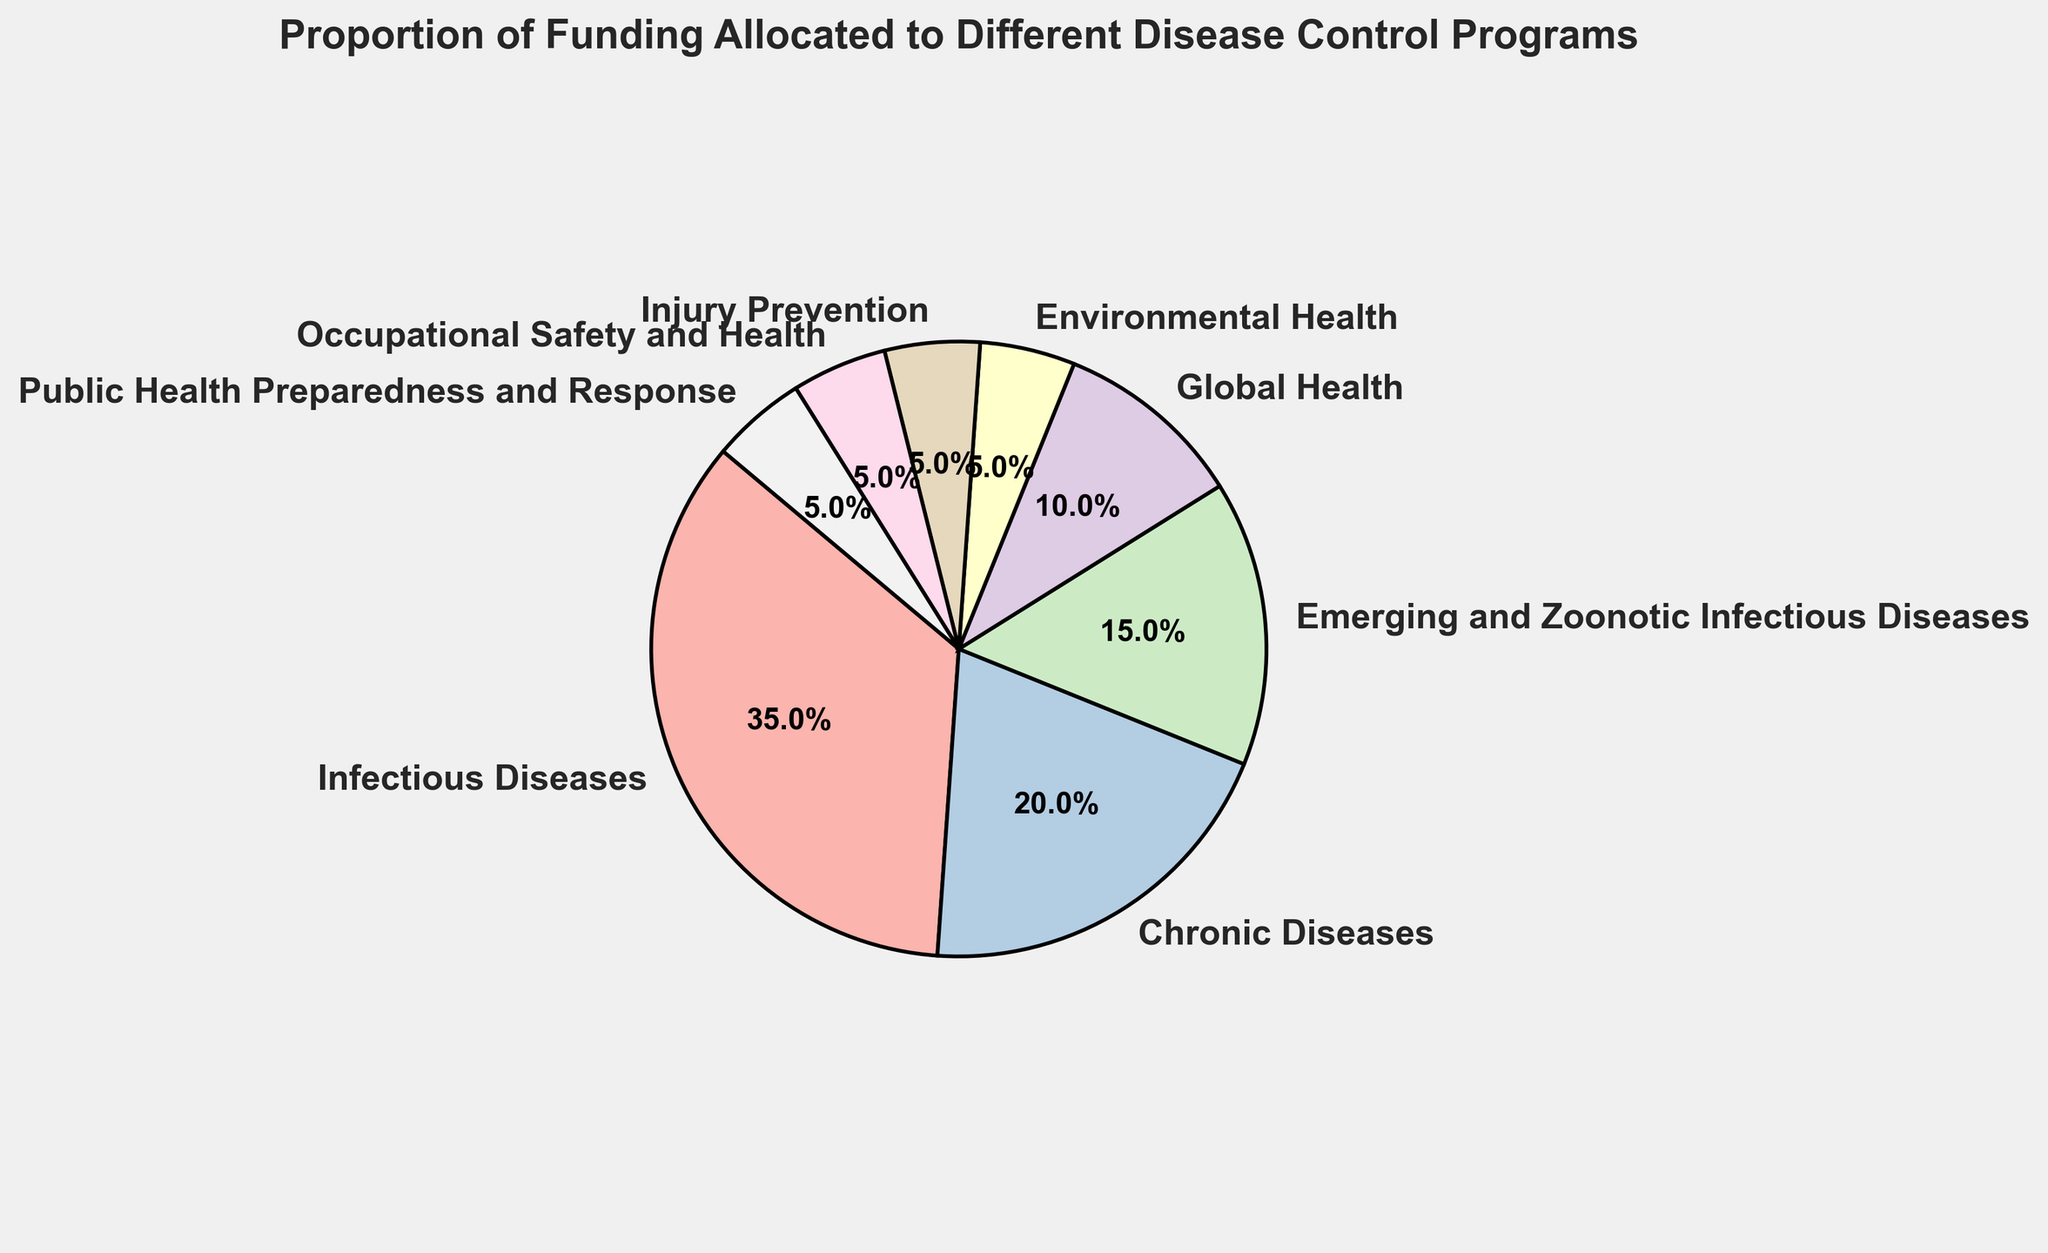Which program receives the highest proportion of funding? By observing the pie chart, the segment labeled "Infectious Diseases" is the largest, indicating it receives the highest proportion of funding
Answer: Infectious Diseases Which program receives the lowest proportion of funding? By observing the pie chart, the smallest segments are labeled "Environmental Health," "Injury Prevention," "Occupational Safety and Health," and "Public Health Preparedness and Response," each receiving the lowest proportion
Answer: Environmental Health, Injury Prevention, Occupational Safety and Health, Public Health Preparedness and Response How much more funding proportion does Infectious Diseases receive compared to Chronic Diseases? The proportion for Infectious Diseases is 35%, and Chronic Diseases is 20%. The difference is calculated as 35% - 20% = 15%
Answer: 15% What is the combined funding proportion for Emerging and Zoonotic Infectious Diseases and Global Health? The proportions for Emerging and Zoonotic Infectious Diseases and Global Health are 15% and 10%, respectively. Summing them gives 15% + 10% = 25%
Answer: 25% What fraction of the total funding is allocated to Chronic Diseases? Chronic Diseases receives 20% of the total funding. To convert this to a fraction, divide by 100: 20% = 20/100 = 1/5
Answer: 1/5 Which programs combined make up half of the total funding? Observing the proportions, Infectious Diseases (35%) and Chronic Diseases (20%) together make up 55%. But looking for exactly 50%, we take Infectious Diseases (35%) and Emerging and Zoonotic Infectious (15%) to sum up exactly 50%
Answer: Infectious Diseases and Emerging and Zoonotic Infectious Diseases Is the funding for Environmental Health equal to the funding for Injury Prevention? Observing the pie chart, both Environmental Health and Injury Prevention have the same proportion of 5%
Answer: Yes What is the total funding proportion for Occupational Safety and Health and Public Health Preparedness and Response together? Both have funding proportions of 5%. Adding them gives 5% + 5% = 10%
Answer: 10% Which program(s) have their proportions visually colored distinctly in the pie chart? By looking at the colors used, we can identify the distinct labeling for categories like Infectious Diseases, Chronic Diseases, and others that use different pastel shades
Answer: All programs If the funding for Global Health were increased by 5%, what would the new proportion be? The current proportion for Global Health is 10%. Adding 5% to this gives 10% + 5% = 15%
Answer: 15% 